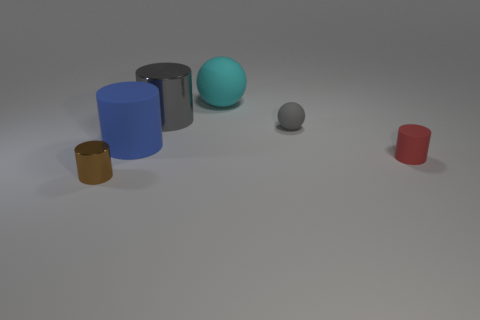Add 1 tiny gray rubber cubes. How many objects exist? 7 Subtract all balls. How many objects are left? 4 Add 6 small matte things. How many small matte things are left? 8 Add 4 big rubber cylinders. How many big rubber cylinders exist? 5 Subtract 1 brown cylinders. How many objects are left? 5 Subtract all blue rubber objects. Subtract all big blue things. How many objects are left? 4 